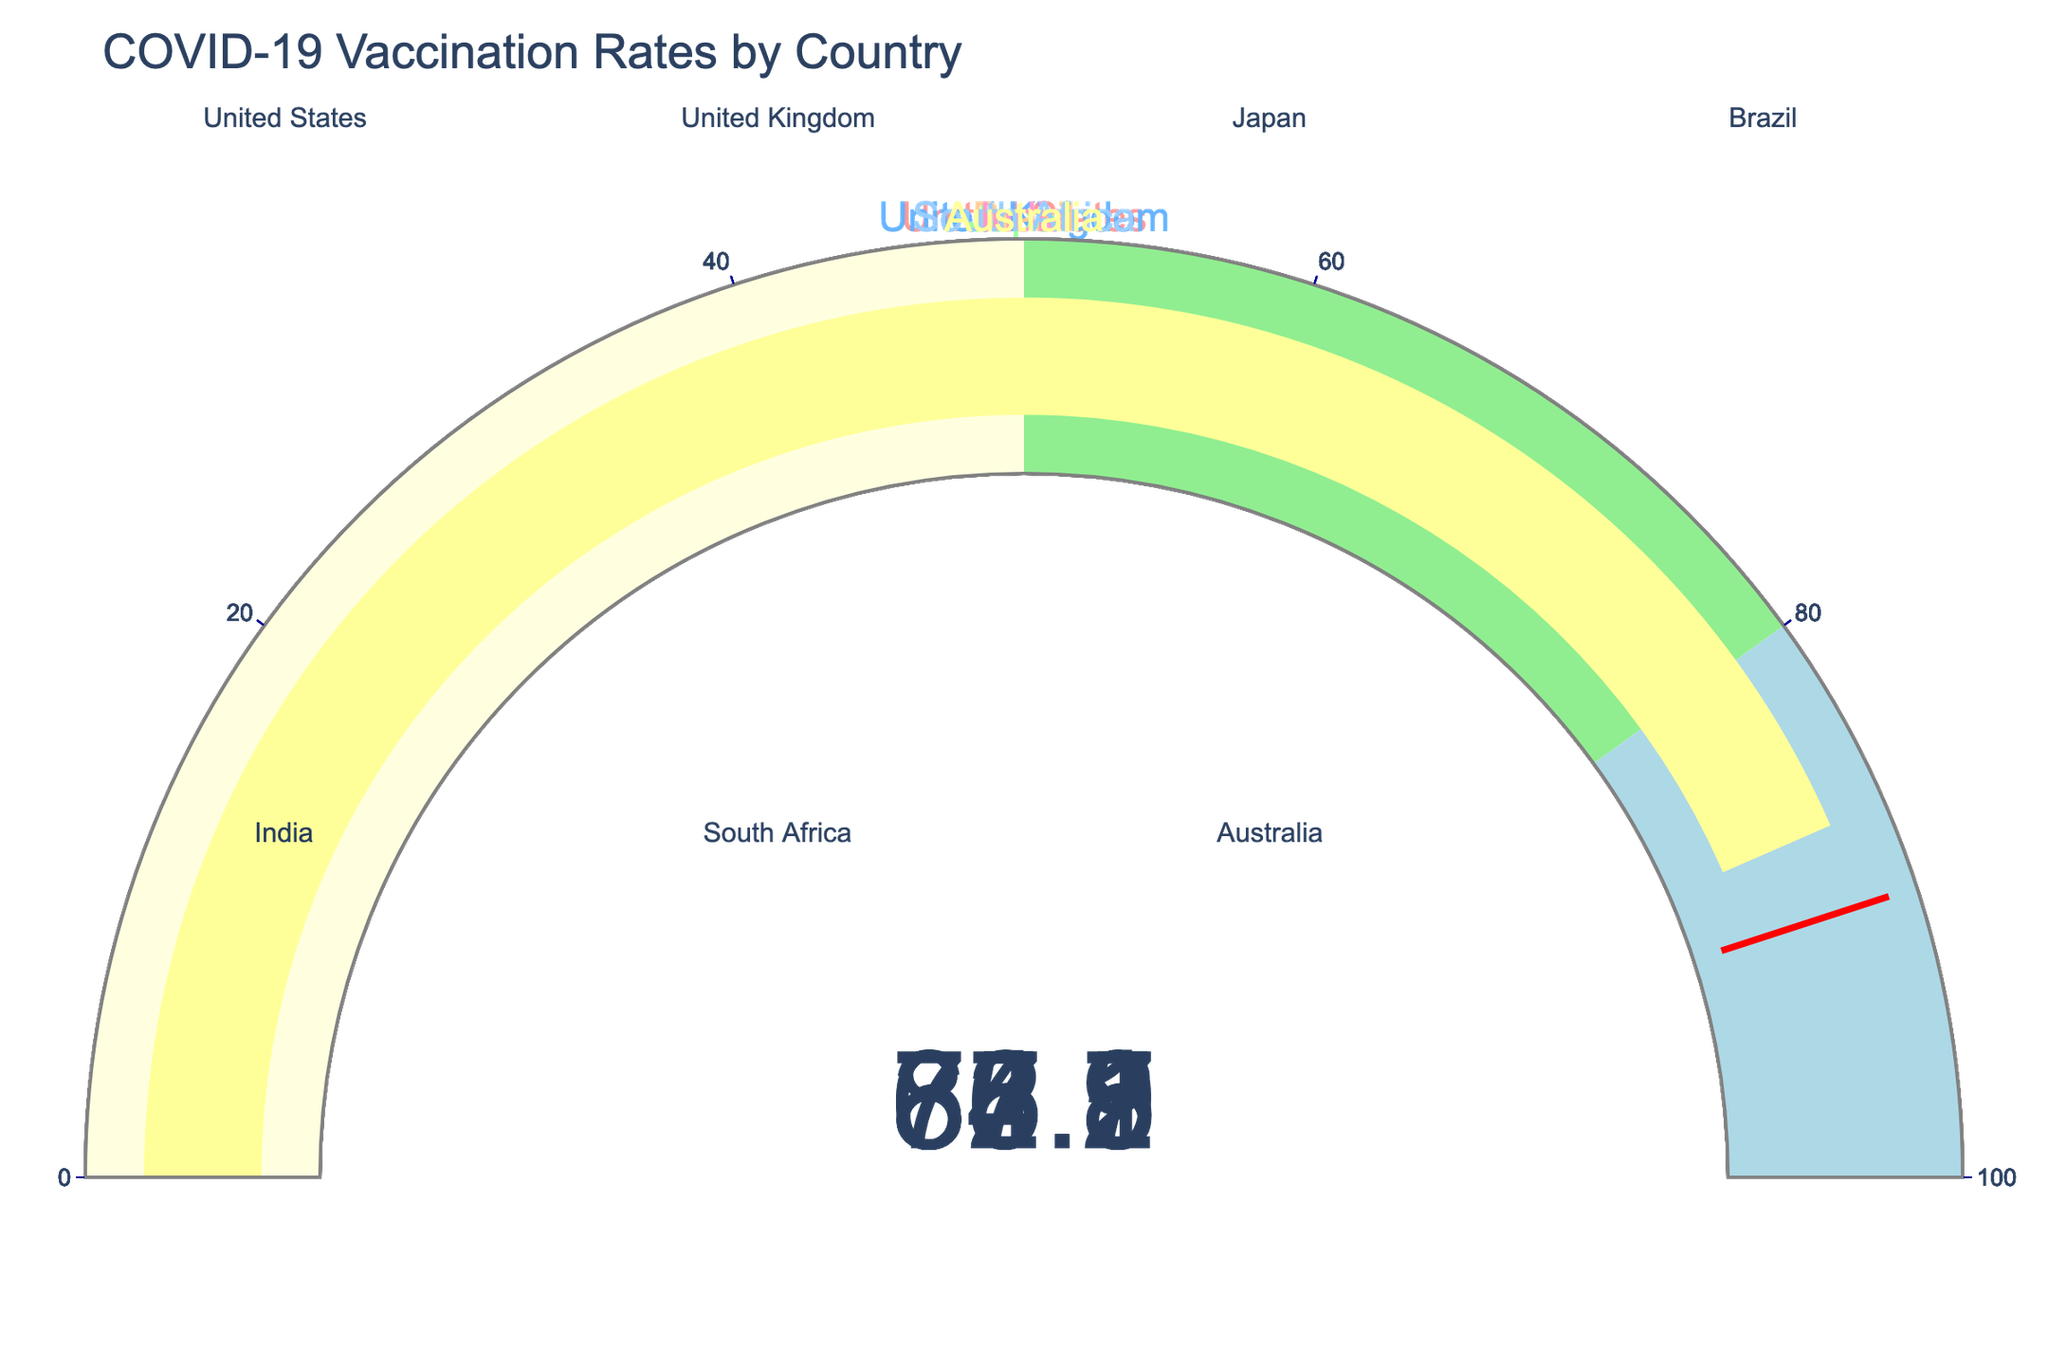What is the vaccination rate of Australia? Australia's vaccination rate is displayed on its gauge as 86.9%
Answer: 86.9% Which country has the lowest vaccination rate? By looking at the gauges, South Africa has the lowest vaccination rate at 35.7%
Answer: South Africa How many countries have a vaccination rate above 80%? From the gauges, Japan, Brazil, and Australia have rates above 80%
Answer: 3 What is the difference in vaccination rates between Brazil and India? Brazil has a rate of 85.1% and India has 62.3%, so the difference is 85.1 - 62.3
Answer: 22.8% Which two countries have vaccination rates closest to each other? The closest rates are for Japan (82.5%) and Brazil (85.1%), with a difference of 2.6%
Answer: Japan and Brazil Does any country have a vaccination rate above 90%? No country has a vaccination rate above the threshold value of 90%
Answer: No What is the title of the figure? The title of the figure is "COVID-19 Vaccination Rates by Country"
Answer: COVID-19 Vaccination Rates by Country How many countries have a vaccination rate below 70%? The countries under 70% are the United States, India, and South Africa, so there are 3
Answer: 3 What is the average vaccination rate of the listed countries? Sum the rates (67.8 + 74.2 + 82.5 + 85.1 + 62.3 + 35.7 + 86.9) to get 494.5, then divide by the number of countries, 7, for the average
Answer: 70.64% Among developed countries, which one has the highest vaccination rate? From the list, Australia, a developed country, has the highest rate at 86.9%
Answer: Australia 